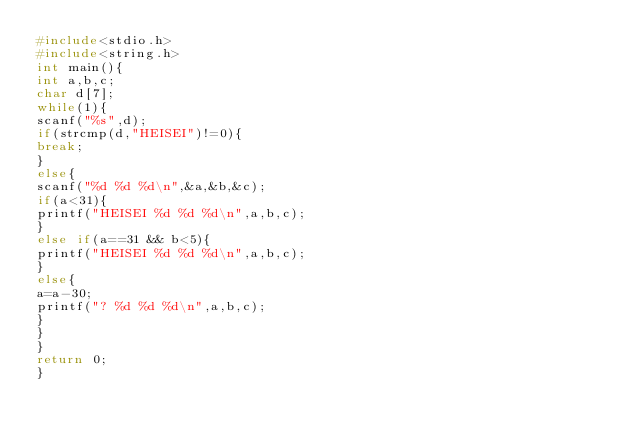<code> <loc_0><loc_0><loc_500><loc_500><_C_>#include<stdio.h>
#include<string.h>
int main(){
int a,b,c;
char d[7];
while(1){
scanf("%s",d);
if(strcmp(d,"HEISEI")!=0){
break;
}
else{
scanf("%d %d %d\n",&a,&b,&c);
if(a<31){
printf("HEISEI %d %d %d\n",a,b,c);
}
else if(a==31 && b<5){
printf("HEISEI %d %d %d\n",a,b,c);
}
else{
a=a-30;
printf("? %d %d %d\n",a,b,c);
}
}
}
return 0;
}
</code> 